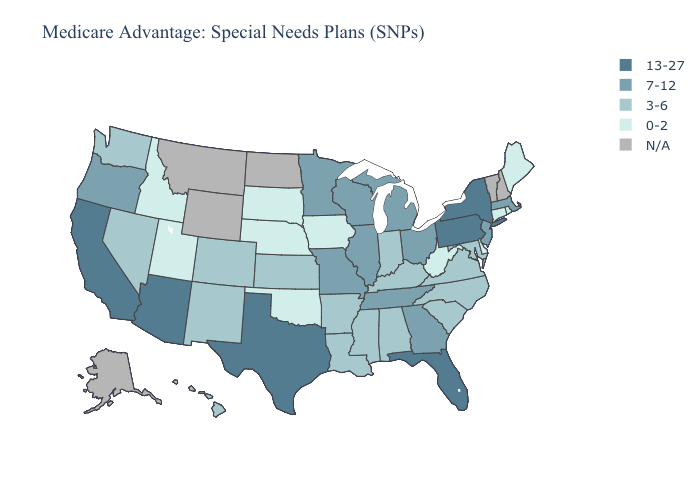Which states have the lowest value in the USA?
Give a very brief answer. Connecticut, Delaware, Iowa, Idaho, Maine, Nebraska, Oklahoma, Rhode Island, South Dakota, Utah, West Virginia. Does Florida have the highest value in the USA?
Quick response, please. Yes. Does Virginia have the lowest value in the USA?
Be succinct. No. What is the lowest value in the USA?
Write a very short answer. 0-2. What is the value of Massachusetts?
Keep it brief. 7-12. Among the states that border Tennessee , which have the highest value?
Write a very short answer. Georgia, Missouri. What is the value of Nevada?
Be succinct. 3-6. What is the value of Idaho?
Be succinct. 0-2. Does Texas have the highest value in the South?
Keep it brief. Yes. What is the highest value in the USA?
Keep it brief. 13-27. What is the highest value in the South ?
Answer briefly. 13-27. Among the states that border Idaho , which have the highest value?
Keep it brief. Oregon. Does Nevada have the lowest value in the West?
Answer briefly. No. 